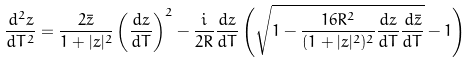<formula> <loc_0><loc_0><loc_500><loc_500>\frac { d ^ { 2 } z } { d T ^ { 2 } } = \frac { 2 \bar { z } } { 1 + | z | ^ { 2 } } \left ( \frac { d z } { d T } \right ) ^ { 2 } - \frac { i } { 2 R } \frac { d z } { d T } \left ( \sqrt { 1 - \frac { 1 6 R ^ { 2 } } { ( 1 + | z | ^ { 2 } ) ^ { 2 } } \frac { d z } { d T } \frac { d \bar { z } } { d T } } - 1 \right )</formula> 